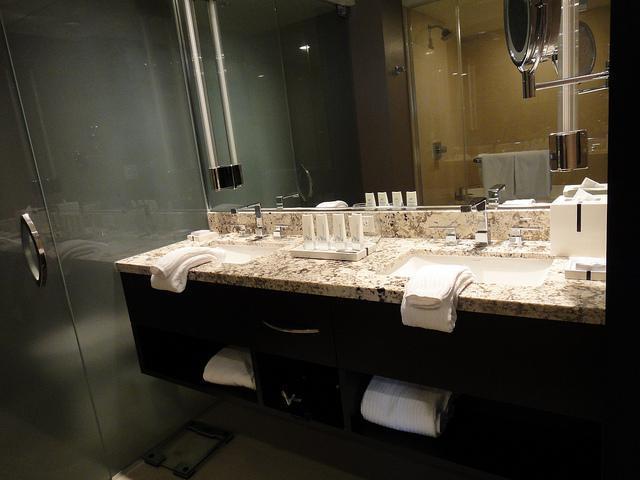How many towels are on the counter?
Give a very brief answer. 4. How many people are visible on skis?
Give a very brief answer. 0. 